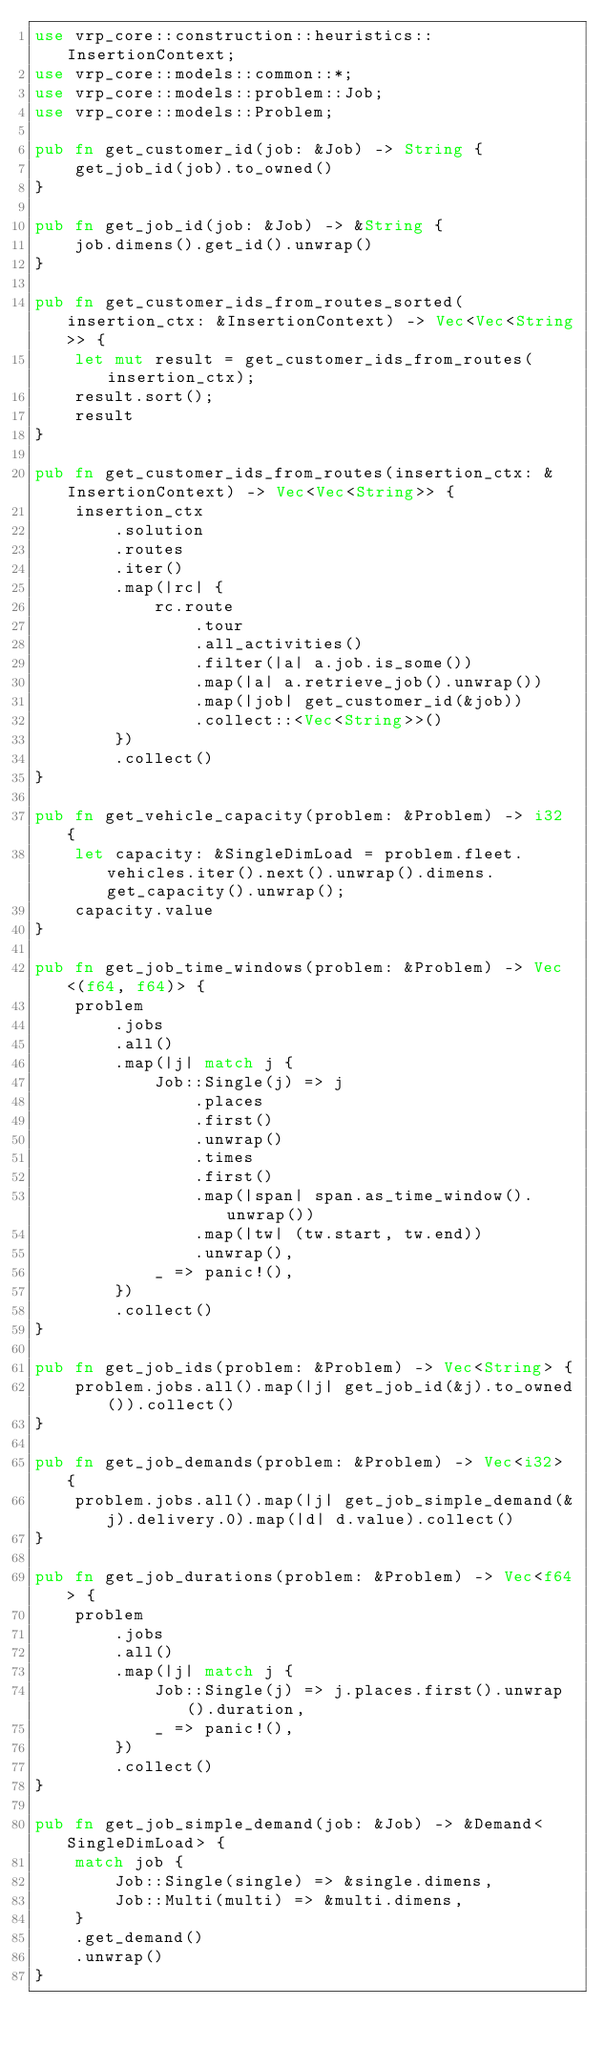Convert code to text. <code><loc_0><loc_0><loc_500><loc_500><_Rust_>use vrp_core::construction::heuristics::InsertionContext;
use vrp_core::models::common::*;
use vrp_core::models::problem::Job;
use vrp_core::models::Problem;

pub fn get_customer_id(job: &Job) -> String {
    get_job_id(job).to_owned()
}

pub fn get_job_id(job: &Job) -> &String {
    job.dimens().get_id().unwrap()
}

pub fn get_customer_ids_from_routes_sorted(insertion_ctx: &InsertionContext) -> Vec<Vec<String>> {
    let mut result = get_customer_ids_from_routes(insertion_ctx);
    result.sort();
    result
}

pub fn get_customer_ids_from_routes(insertion_ctx: &InsertionContext) -> Vec<Vec<String>> {
    insertion_ctx
        .solution
        .routes
        .iter()
        .map(|rc| {
            rc.route
                .tour
                .all_activities()
                .filter(|a| a.job.is_some())
                .map(|a| a.retrieve_job().unwrap())
                .map(|job| get_customer_id(&job))
                .collect::<Vec<String>>()
        })
        .collect()
}

pub fn get_vehicle_capacity(problem: &Problem) -> i32 {
    let capacity: &SingleDimLoad = problem.fleet.vehicles.iter().next().unwrap().dimens.get_capacity().unwrap();
    capacity.value
}

pub fn get_job_time_windows(problem: &Problem) -> Vec<(f64, f64)> {
    problem
        .jobs
        .all()
        .map(|j| match j {
            Job::Single(j) => j
                .places
                .first()
                .unwrap()
                .times
                .first()
                .map(|span| span.as_time_window().unwrap())
                .map(|tw| (tw.start, tw.end))
                .unwrap(),
            _ => panic!(),
        })
        .collect()
}

pub fn get_job_ids(problem: &Problem) -> Vec<String> {
    problem.jobs.all().map(|j| get_job_id(&j).to_owned()).collect()
}

pub fn get_job_demands(problem: &Problem) -> Vec<i32> {
    problem.jobs.all().map(|j| get_job_simple_demand(&j).delivery.0).map(|d| d.value).collect()
}

pub fn get_job_durations(problem: &Problem) -> Vec<f64> {
    problem
        .jobs
        .all()
        .map(|j| match j {
            Job::Single(j) => j.places.first().unwrap().duration,
            _ => panic!(),
        })
        .collect()
}

pub fn get_job_simple_demand(job: &Job) -> &Demand<SingleDimLoad> {
    match job {
        Job::Single(single) => &single.dimens,
        Job::Multi(multi) => &multi.dimens,
    }
    .get_demand()
    .unwrap()
}
</code> 